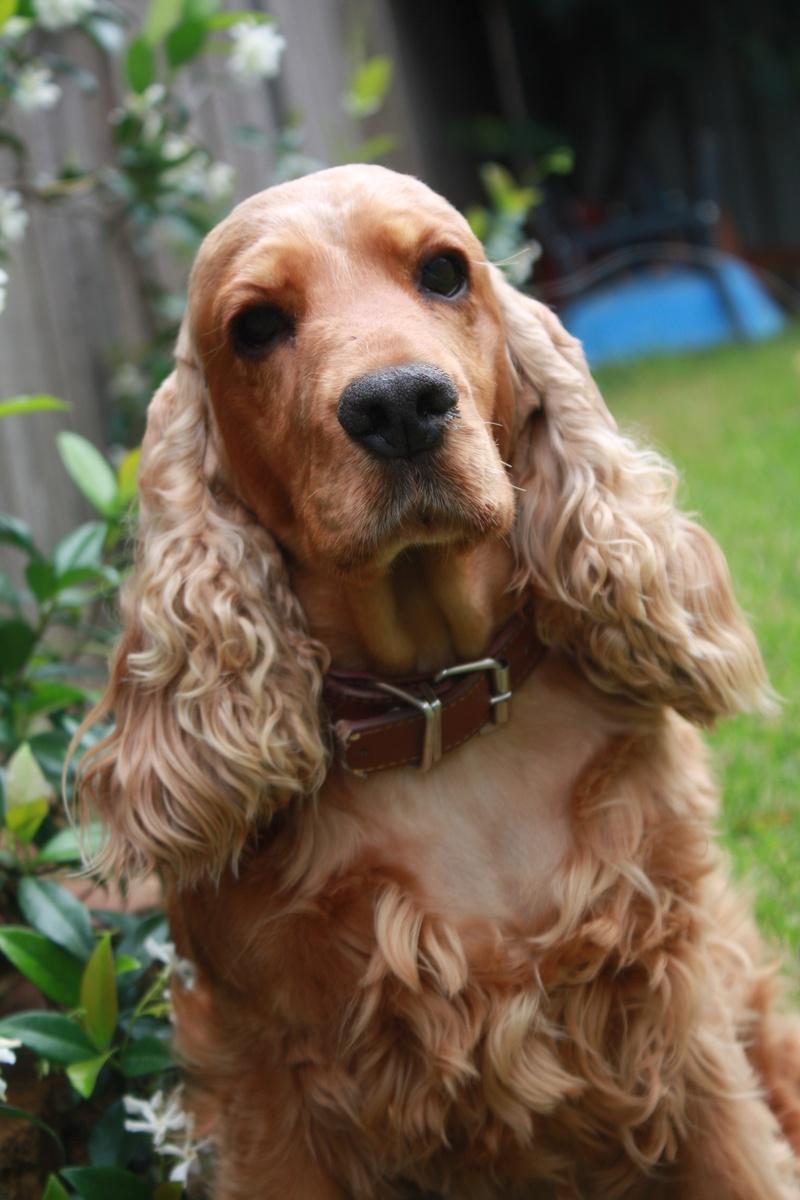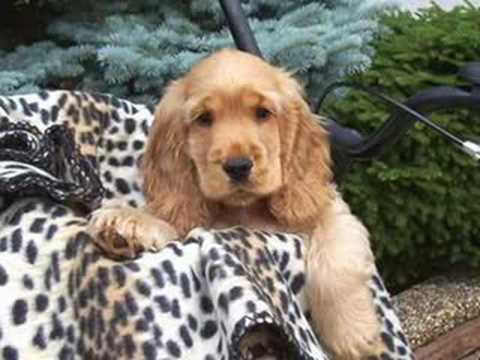The first image is the image on the left, the second image is the image on the right. For the images shown, is this caption "Exactly two dogs are shown with background settings, each of them the same tan coloring with dark eyes, one wearing a collar and the other not" true? Answer yes or no. Yes. The first image is the image on the left, the second image is the image on the right. Assess this claim about the two images: "An image shows a reddish spaniel dog with its paws over a blanket-like piece of fabric.". Correct or not? Answer yes or no. Yes. 